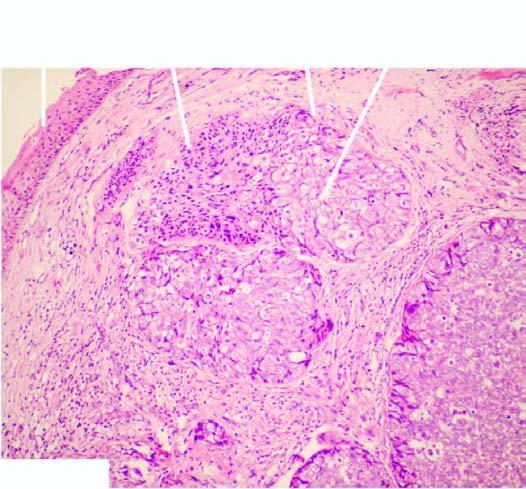re renal tubules and glomeruli arranged as lobules with peripheral basaloid cells and pale cells in the centre?
Answer the question using a single word or phrase. No 